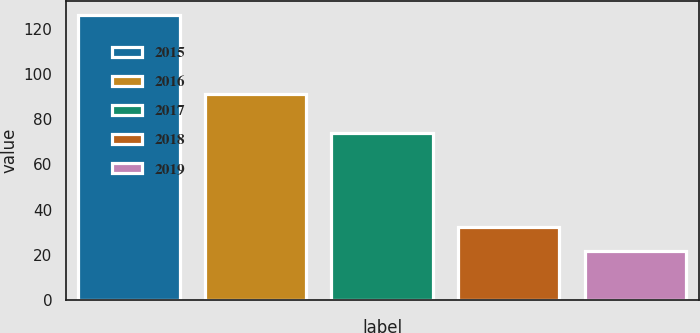Convert chart to OTSL. <chart><loc_0><loc_0><loc_500><loc_500><bar_chart><fcel>2015<fcel>2016<fcel>2017<fcel>2018<fcel>2019<nl><fcel>126<fcel>91<fcel>74<fcel>32.4<fcel>22<nl></chart> 